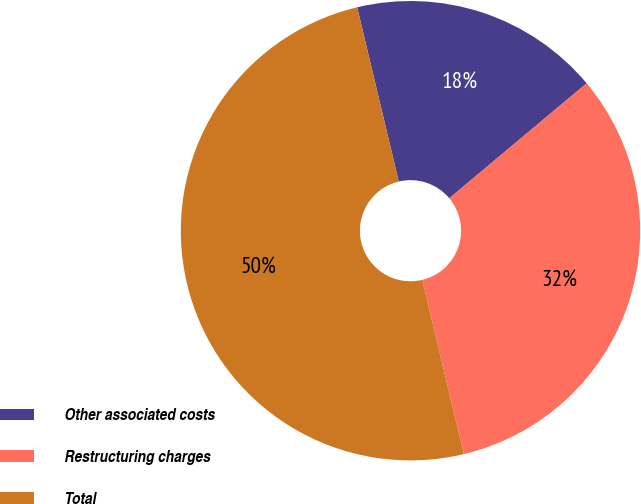Convert chart to OTSL. <chart><loc_0><loc_0><loc_500><loc_500><pie_chart><fcel>Other associated costs<fcel>Restructuring charges<fcel>Total<nl><fcel>17.64%<fcel>32.36%<fcel>50.0%<nl></chart> 